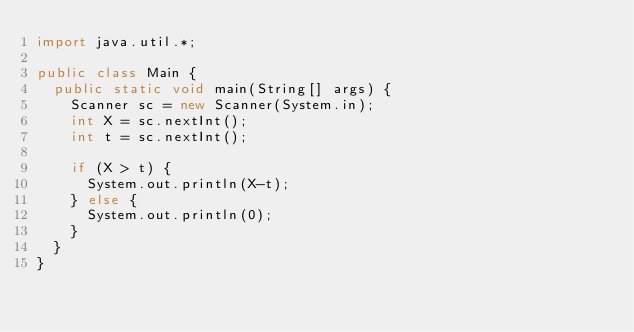<code> <loc_0><loc_0><loc_500><loc_500><_Java_>import java.util.*;

public class Main {
  public static void main(String[] args) {
    Scanner sc = new Scanner(System.in);
    int X = sc.nextInt();
    int t = sc.nextInt();
    
    if (X > t) {
      System.out.println(X-t);
    } else {
      System.out.println(0);
    }
  }
}</code> 